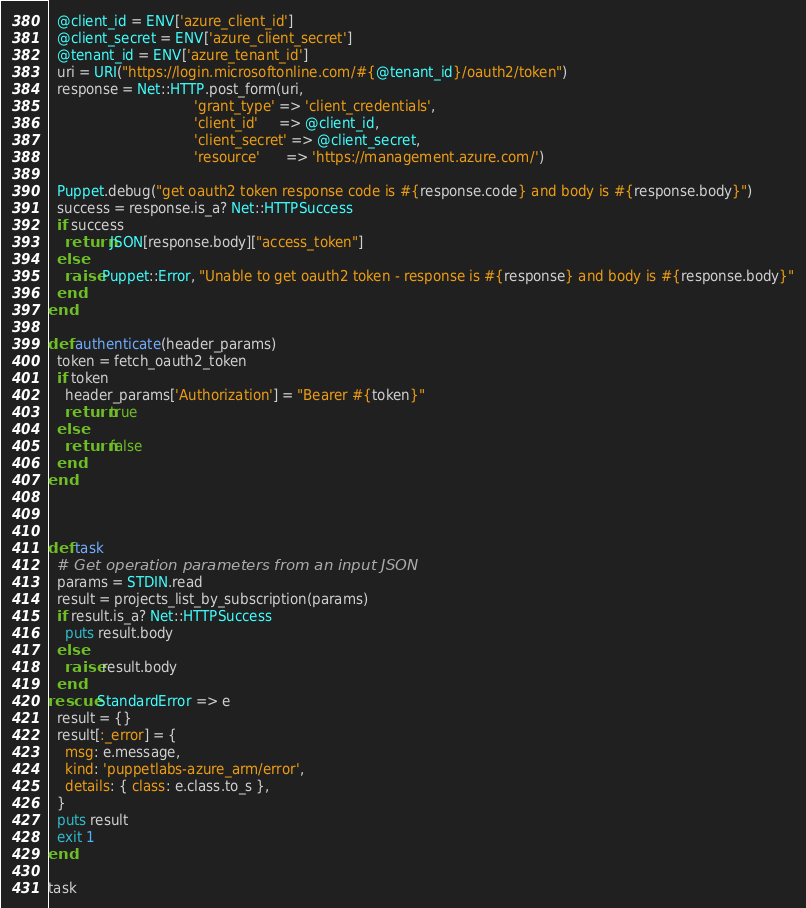Convert code to text. <code><loc_0><loc_0><loc_500><loc_500><_Ruby_>  @client_id = ENV['azure_client_id']
  @client_secret = ENV['azure_client_secret']
  @tenant_id = ENV['azure_tenant_id']
  uri = URI("https://login.microsoftonline.com/#{@tenant_id}/oauth2/token")
  response = Net::HTTP.post_form(uri,
                                  'grant_type' => 'client_credentials',
                                  'client_id'     => @client_id,
                                  'client_secret' => @client_secret,
                                  'resource'      => 'https://management.azure.com/')

  Puppet.debug("get oauth2 token response code is #{response.code} and body is #{response.body}")
  success = response.is_a? Net::HTTPSuccess
  if success
    return JSON[response.body]["access_token"]
  else
    raise Puppet::Error, "Unable to get oauth2 token - response is #{response} and body is #{response.body}"
  end
end

def authenticate(header_params)
  token = fetch_oauth2_token
  if token
    header_params['Authorization'] = "Bearer #{token}"
    return true
  else
    return false
  end
end



def task
  # Get operation parameters from an input JSON
  params = STDIN.read
  result = projects_list_by_subscription(params)
  if result.is_a? Net::HTTPSuccess
    puts result.body
  else
    raise result.body
  end
rescue StandardError => e
  result = {}
  result[:_error] = {
    msg: e.message,
    kind: 'puppetlabs-azure_arm/error',
    details: { class: e.class.to_s },
  }
  puts result
  exit 1
end

task</code> 